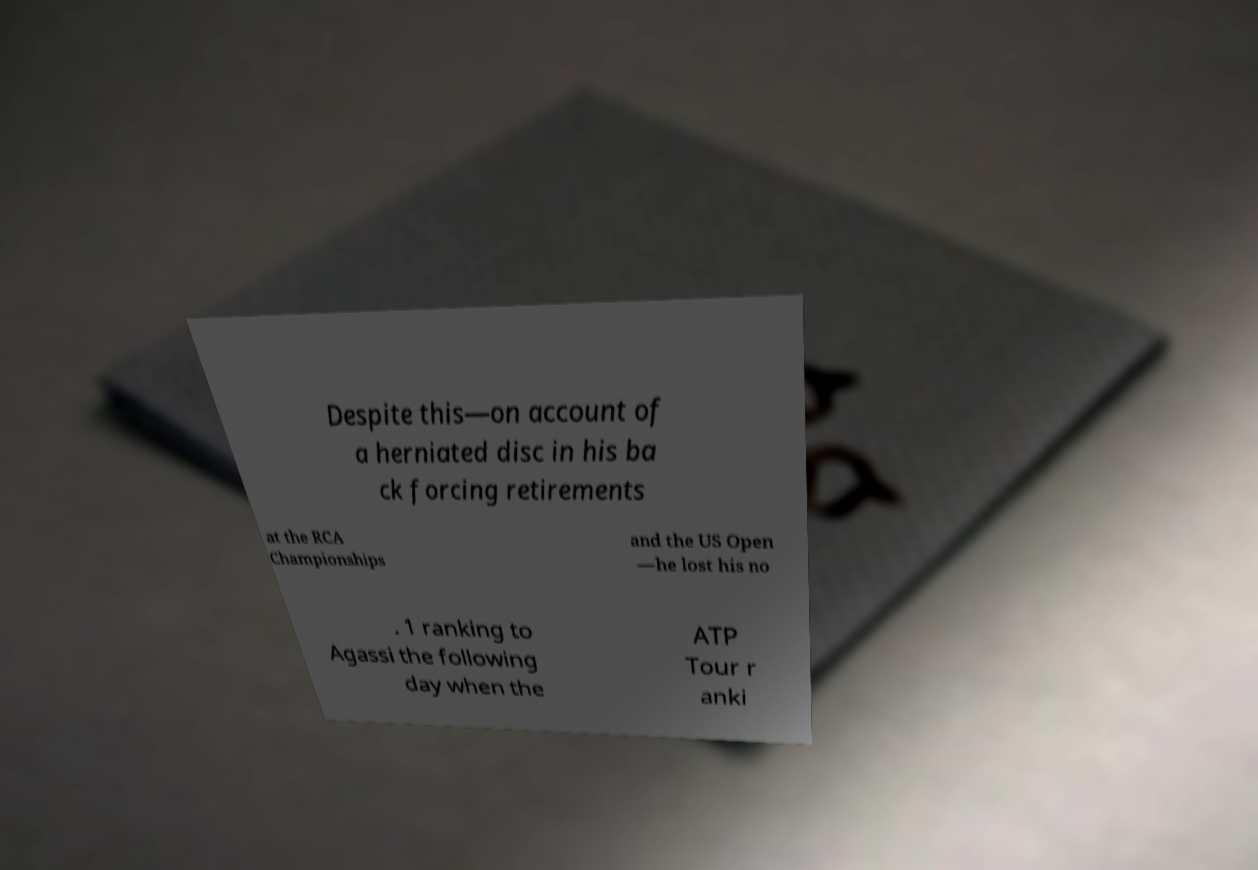Please identify and transcribe the text found in this image. Despite this—on account of a herniated disc in his ba ck forcing retirements at the RCA Championships and the US Open —he lost his no . 1 ranking to Agassi the following day when the ATP Tour r anki 